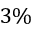Convert formula to latex. <formula><loc_0><loc_0><loc_500><loc_500>3 \%</formula> 